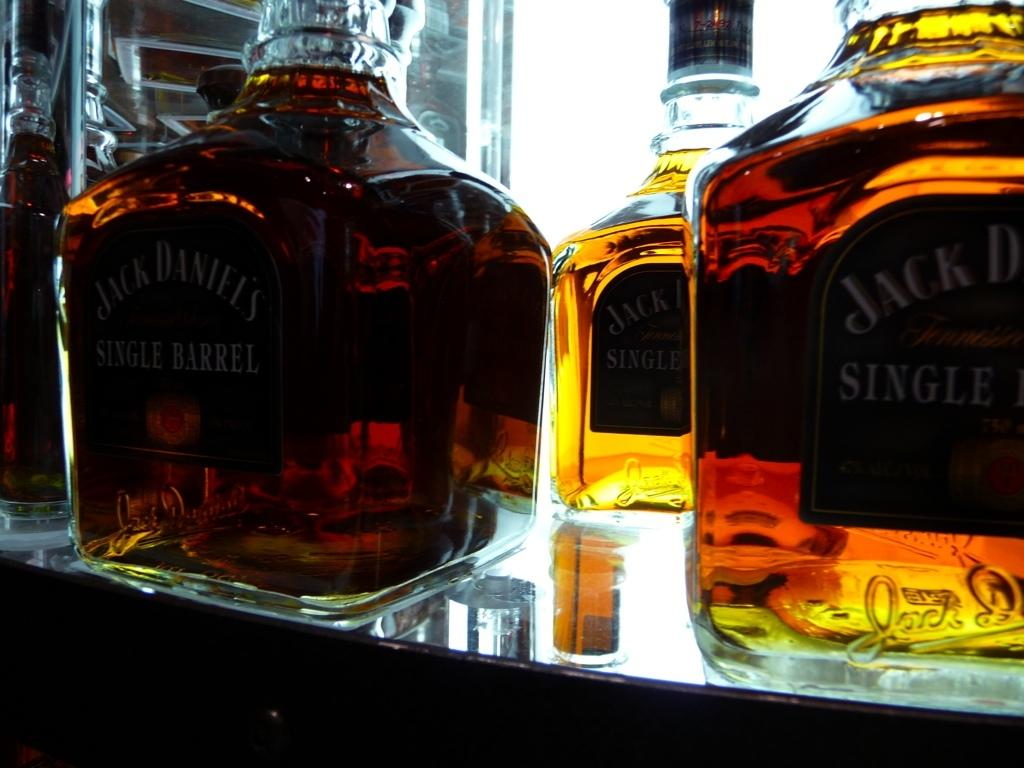<image>
Write a terse but informative summary of the picture. Several bottles of Jack Daniel's are on a lighted shelf. 